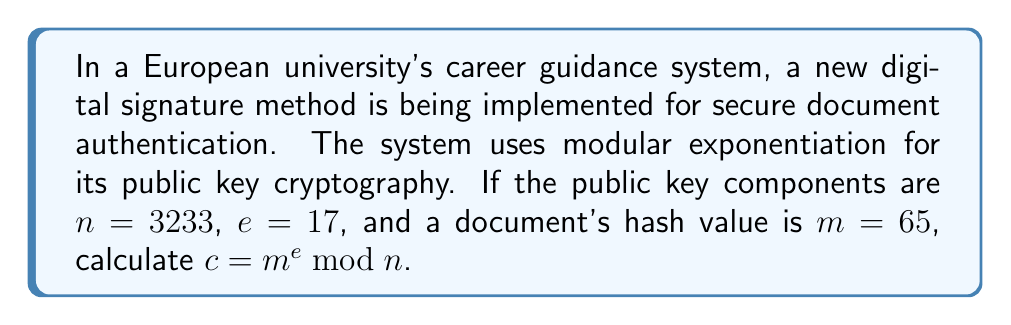Can you answer this question? To calculate the modular exponentiation $c = m^e \bmod n$, we need to follow these steps:

1. Identify the values:
   $m = 65$ (document hash value)
   $e = 17$ (public exponent)
   $n = 3233$ (modulus)

2. We need to calculate $65^{17} \bmod 3233$. This is a large number, so we'll use the square-and-multiply algorithm:

3. Convert the exponent (17) to binary: $17_{10} = 10001_2$

4. Initialize: $result = 1$, $base = 65$

5. For each bit in the binary exponent (from left to right):
   a) Square the result: $result = result^2 \bmod 3233$
   b) If the bit is 1, multiply by the base: $result = (result \times base) \bmod 3233$

6. Calculations:
   Bit 1: $result = 1^2 \bmod 3233 = 1$, then $result = (1 \times 65) \bmod 3233 = 65$
   Bit 0: $result = 65^2 \bmod 3233 = 4225 \bmod 3233 = 992$
   Bit 0: $result = 992^2 \bmod 3233 = 984064 \bmod 3233 = 2311$
   Bit 0: $result = 2311^2 \bmod 3233 = 5340721 \bmod 3233 = 2167$
   Bit 1: $result = 2167^2 \bmod 3233 = 4695889 \bmod 3233 = 2075$
          $result = (2075 \times 65) \bmod 3233 = 134875 \bmod 3233 = 2981$

7. The final result is 2981.
Answer: $2981$ 